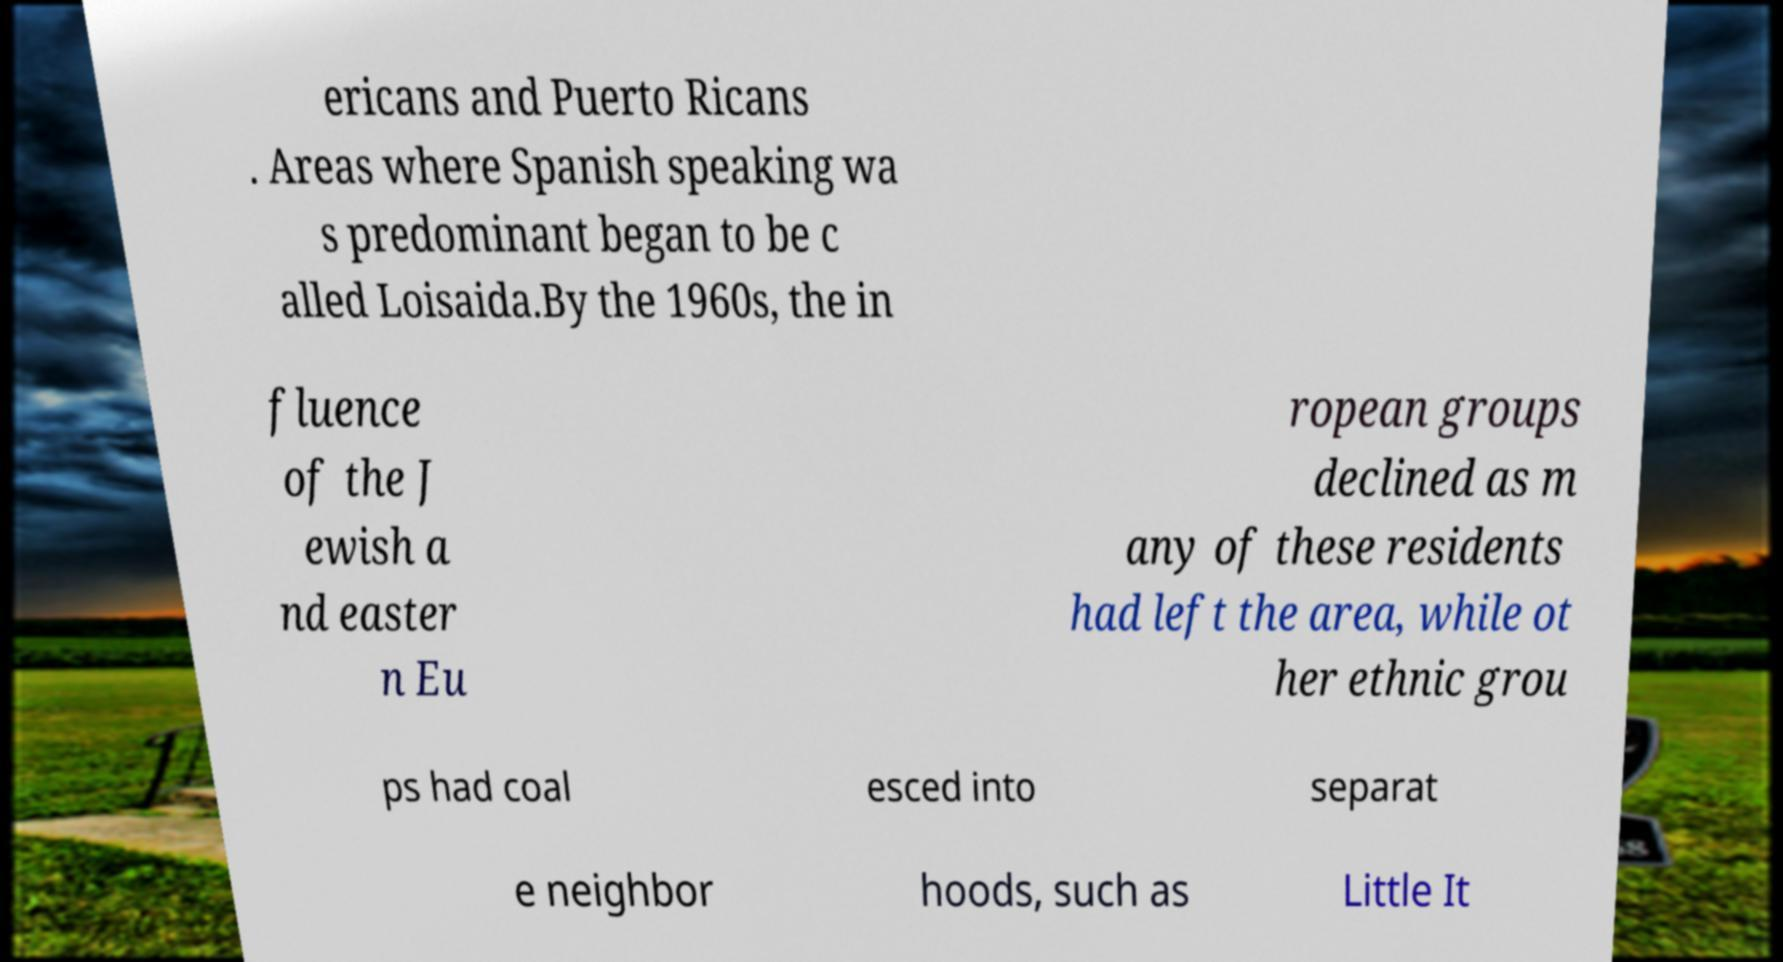Can you accurately transcribe the text from the provided image for me? ericans and Puerto Ricans . Areas where Spanish speaking wa s predominant began to be c alled Loisaida.By the 1960s, the in fluence of the J ewish a nd easter n Eu ropean groups declined as m any of these residents had left the area, while ot her ethnic grou ps had coal esced into separat e neighbor hoods, such as Little It 